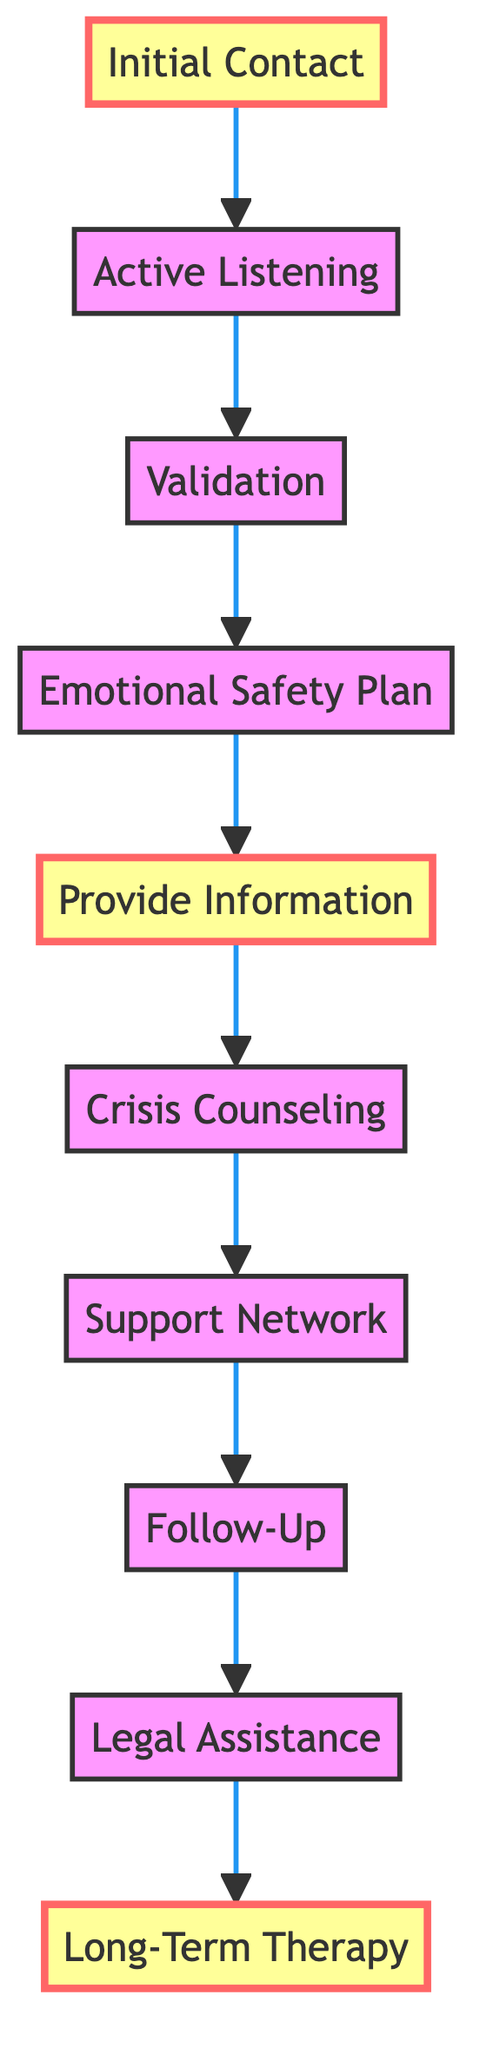What is the first step in providing emotional support to rape victims? The diagram starts with the node "Initial Contact," indicating that this is the first step in the emotional support process.
Answer: Initial Contact How many total steps are in the flowchart? By counting the nodes in the diagram, we find that there are ten distinct steps listed in the flowchart.
Answer: 10 Which step follows "Emotional Safety Plan"? The flowchart indicates that "Provide Information" directly follows the "Emotional Safety Plan" step, showing the sequence of actions.
Answer: Provide Information What are the highlighted steps in the flowchart? The highlighted steps are "Initial Contact," "Provide Information," and "Long-Term Therapy," indicating key components in the emotional support process.
Answer: Initial Contact, Provide Information, Long-Term Therapy What is the last step in the flowchart? The flowchart ends with the node "Long-Term Therapy," which is the final step for providing ongoing emotional support.
Answer: Long-Term Therapy How does "Active Listening" relate to "Validation"? The flowchart shows that "Active Listening" directly leads to "Validation," indicating that listening is an essential precursor to validation in the support process.
Answer: It proceeds to Validation Which step connects "Crisis Counseling" to "Support Network"? The diagram shows that "Crisis Counseling" leads directly into "Support Network," establishing a relationship between these two steps in terms of support resources.
Answer: Support Network What is the purpose of the "Follow-Up" step? The "Follow-Up" step emphasizes the importance of checking on the victim's progress and emotional well-being after initial support has been provided, indicating continued care.
Answer: Check on progress and well-being 